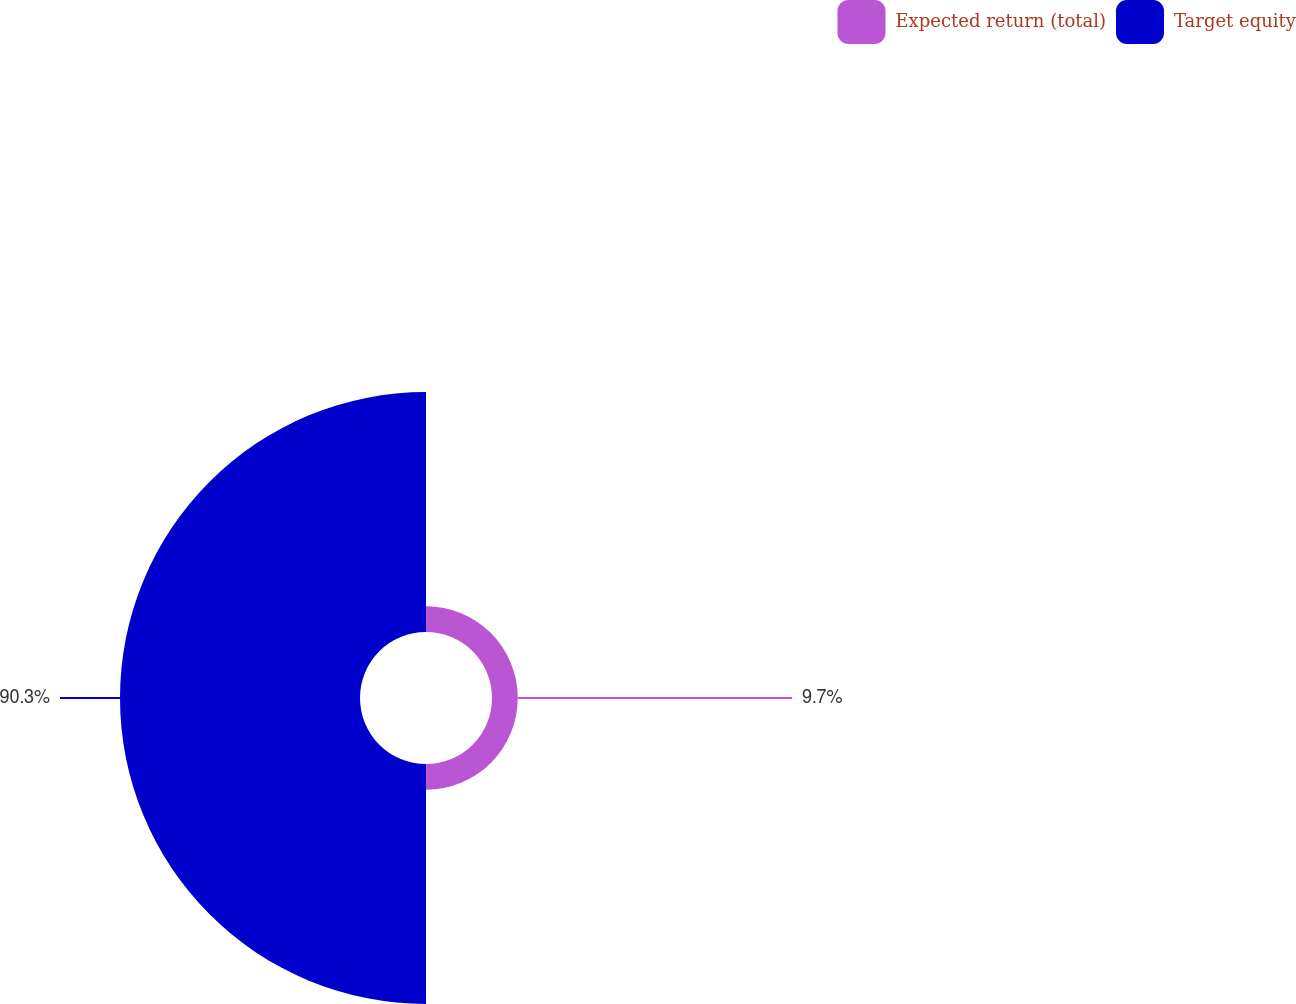Convert chart to OTSL. <chart><loc_0><loc_0><loc_500><loc_500><pie_chart><fcel>Expected return (total)<fcel>Target equity<nl><fcel>9.7%<fcel>90.3%<nl></chart> 